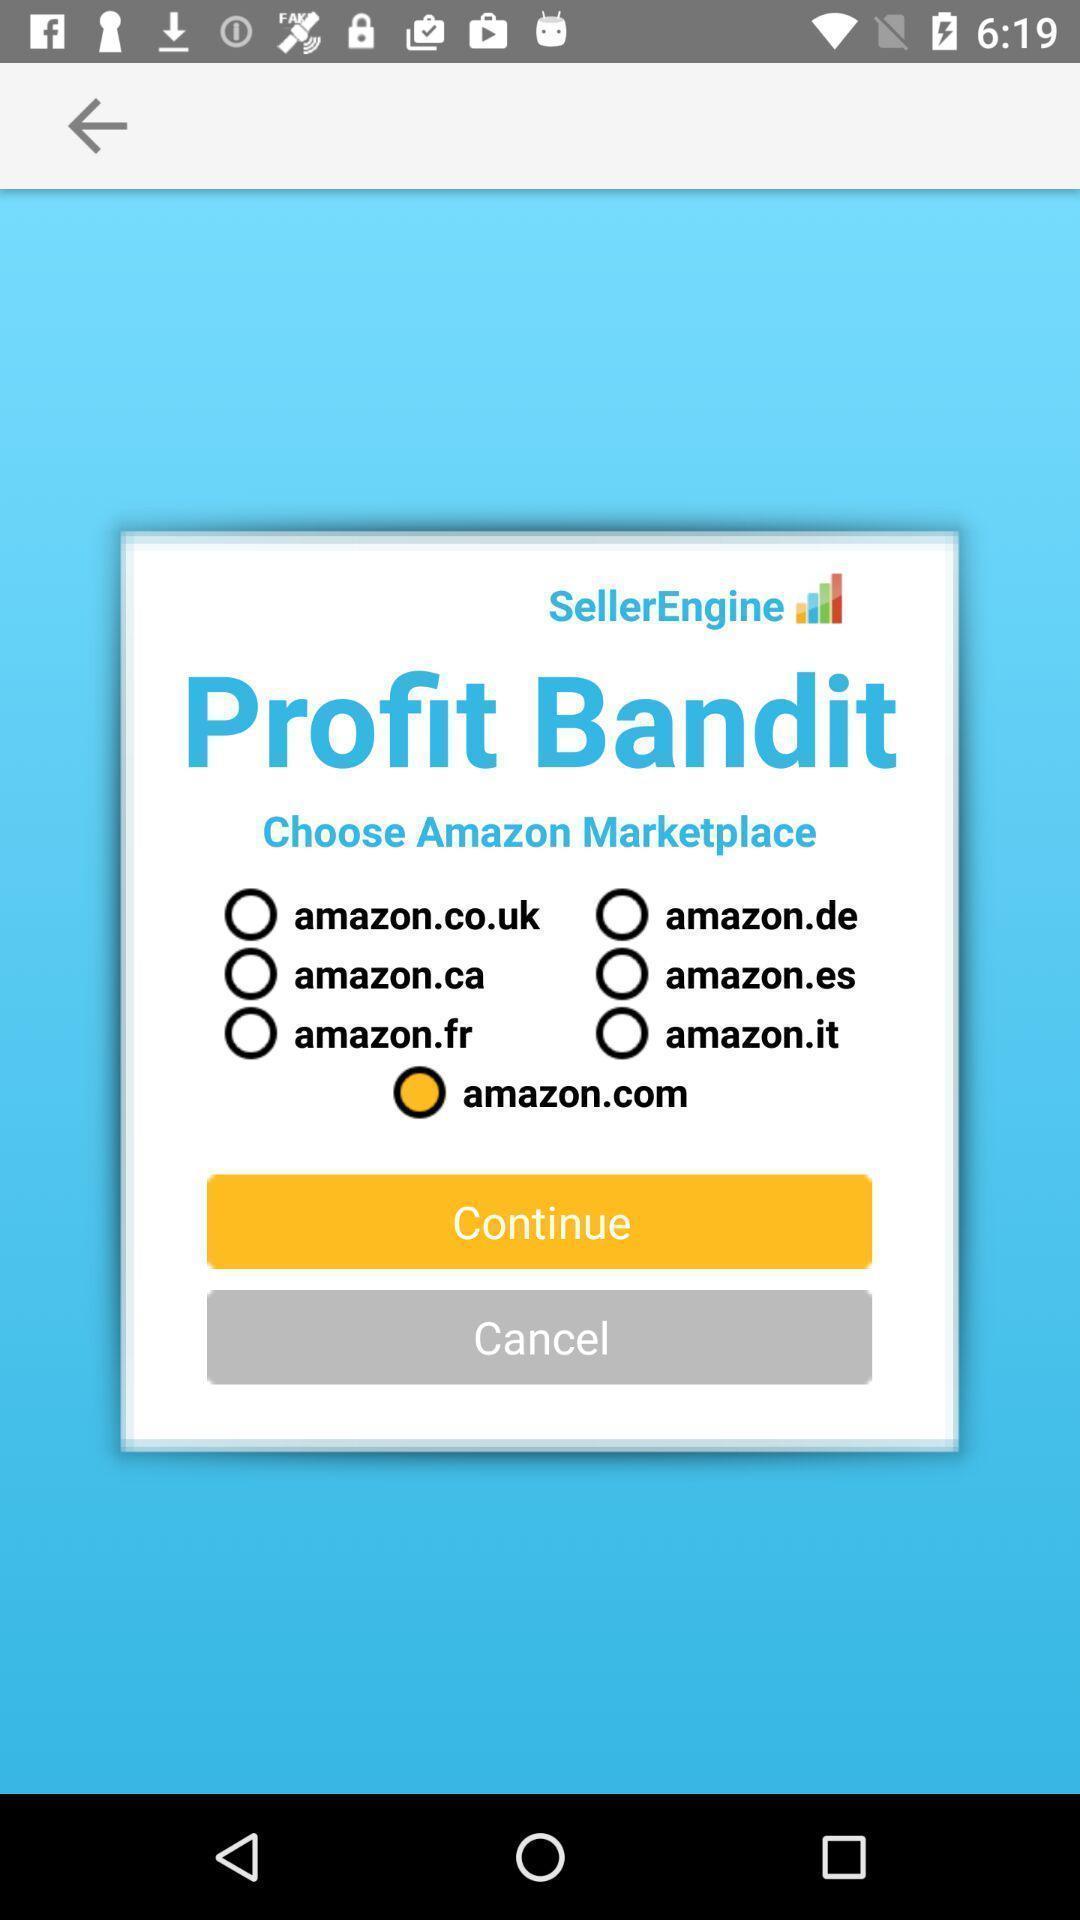What is the overall content of this screenshot? Screen displaying the page of a market app. 